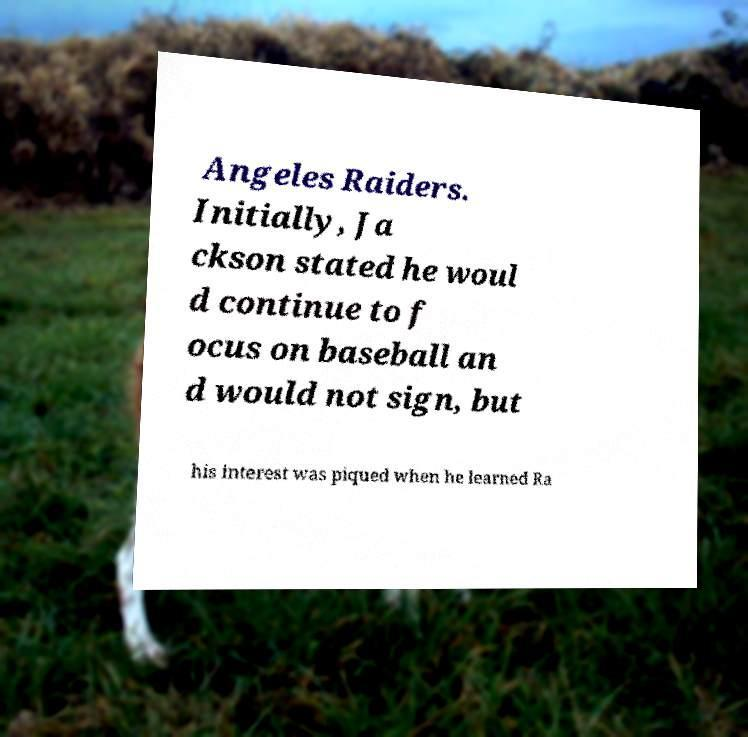What messages or text are displayed in this image? I need them in a readable, typed format. Angeles Raiders. Initially, Ja ckson stated he woul d continue to f ocus on baseball an d would not sign, but his interest was piqued when he learned Ra 